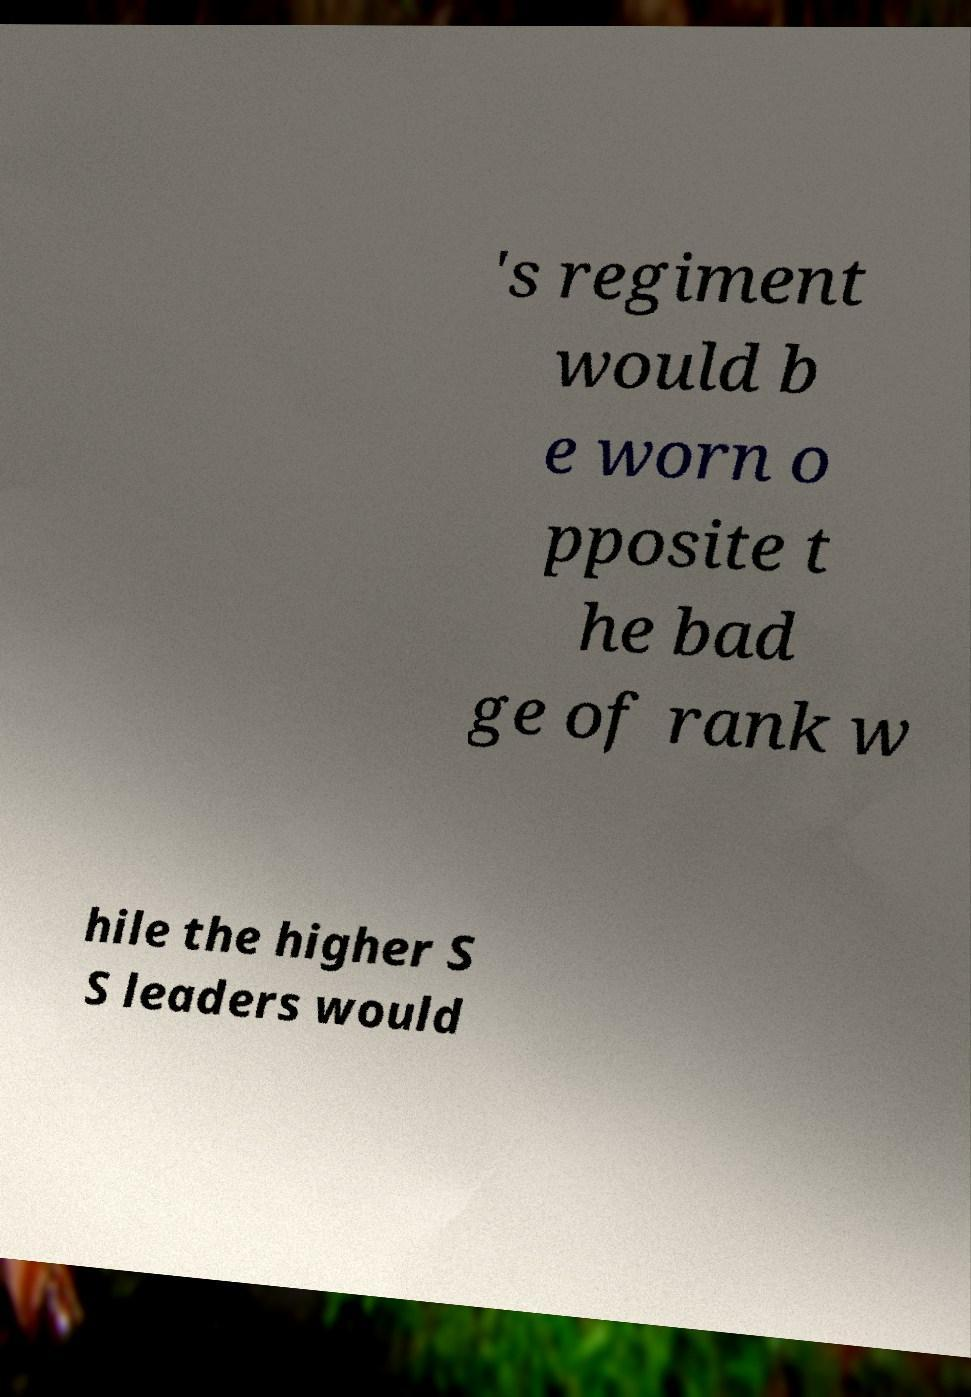There's text embedded in this image that I need extracted. Can you transcribe it verbatim? 's regiment would b e worn o pposite t he bad ge of rank w hile the higher S S leaders would 